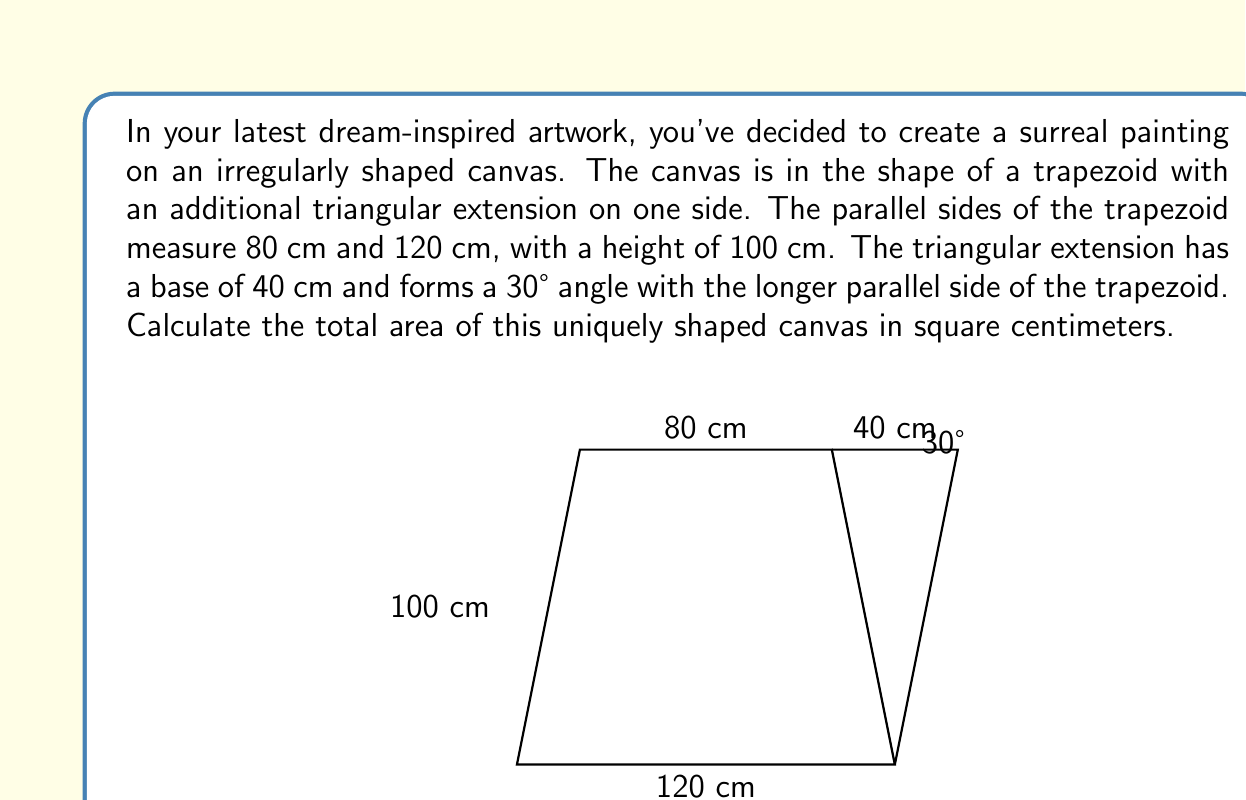Can you answer this question? To find the total area of the canvas, we need to calculate the area of the trapezoid and the area of the triangular extension separately, then add them together.

1. Area of the trapezoid:
   The formula for the area of a trapezoid is:
   $$A_{trapezoid} = \frac{1}{2}(b_1 + b_2)h$$
   where $b_1$ and $b_2$ are the parallel sides and $h$ is the height.

   $$A_{trapezoid} = \frac{1}{2}(80 + 120) \times 100 = 10,000 \text{ cm}^2$$

2. Area of the triangular extension:
   We need to find the height of this triangle first. Let's call this height $h$.
   We can use the trigonometric function tangent:

   $$\tan 30° = \frac{h}{40}$$
   $$h = 40 \tan 30° = 40 \times \frac{1}{\sqrt{3}} \approx 23.09 \text{ cm}$$

   Now we can calculate the area of the triangle:
   $$A_{triangle} = \frac{1}{2} \times 40 \times 23.09 \approx 461.88 \text{ cm}^2$$

3. Total area:
   $$A_{total} = A_{trapezoid} + A_{triangle}$$
   $$A_{total} = 10,000 + 461.88 = 10,461.88 \text{ cm}^2$$
Answer: The total area of the irregularly shaped canvas is approximately 10,461.88 cm². 